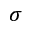Convert formula to latex. <formula><loc_0><loc_0><loc_500><loc_500>\sigma</formula> 